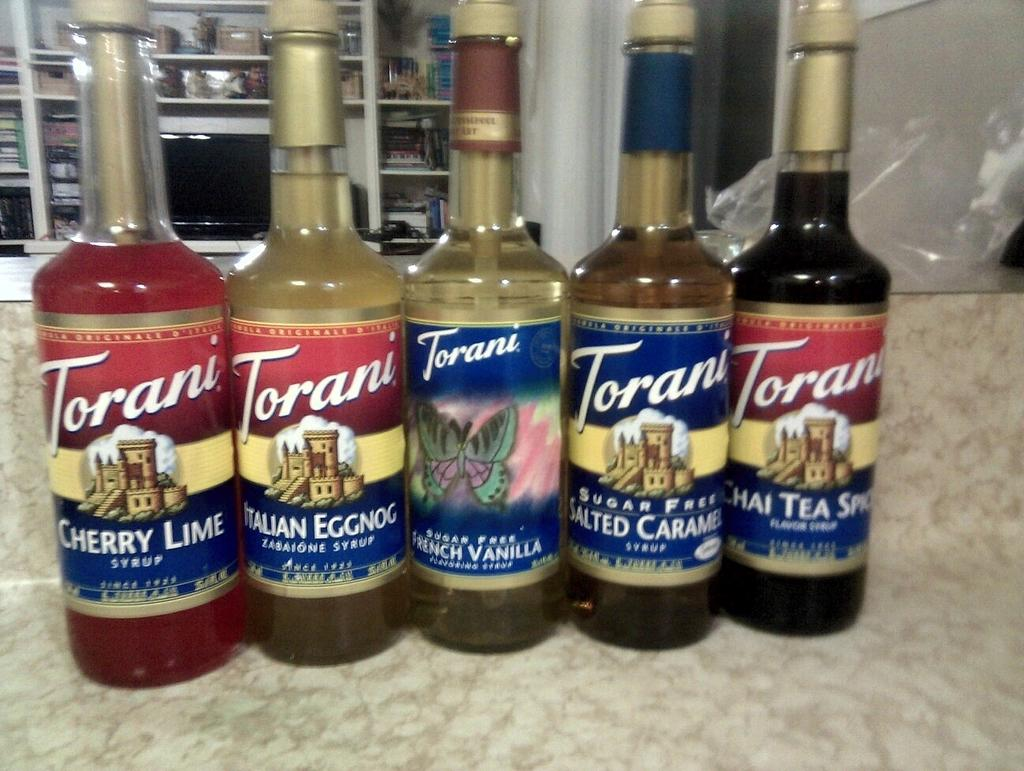<image>
Write a terse but informative summary of the picture. Five different flavors of Torani syrup are lined up. 